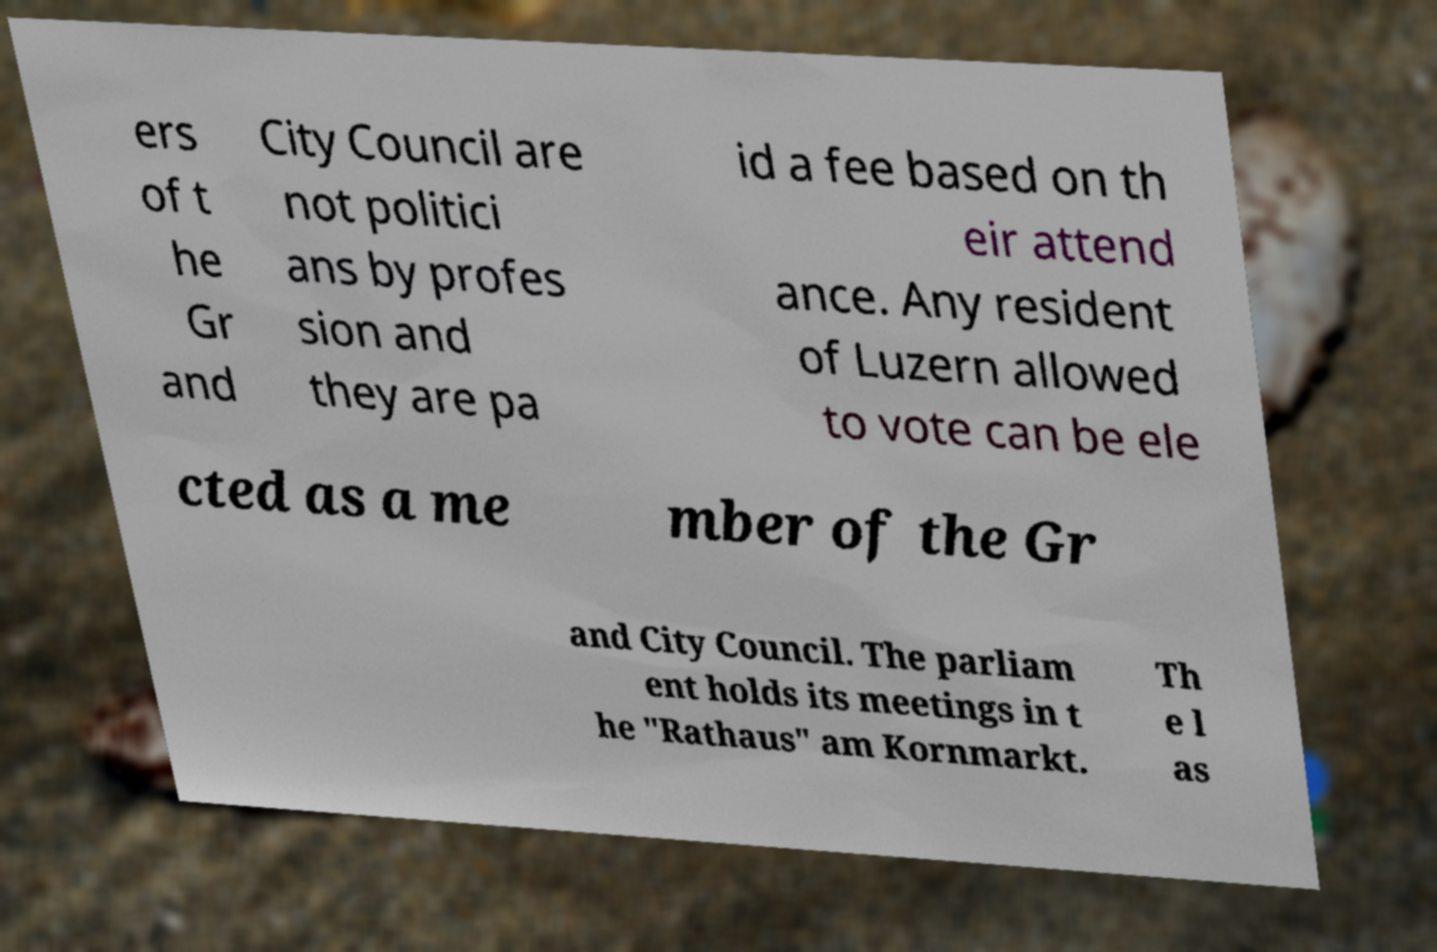Can you read and provide the text displayed in the image?This photo seems to have some interesting text. Can you extract and type it out for me? ers of t he Gr and City Council are not politici ans by profes sion and they are pa id a fee based on th eir attend ance. Any resident of Luzern allowed to vote can be ele cted as a me mber of the Gr and City Council. The parliam ent holds its meetings in t he "Rathaus" am Kornmarkt. Th e l as 